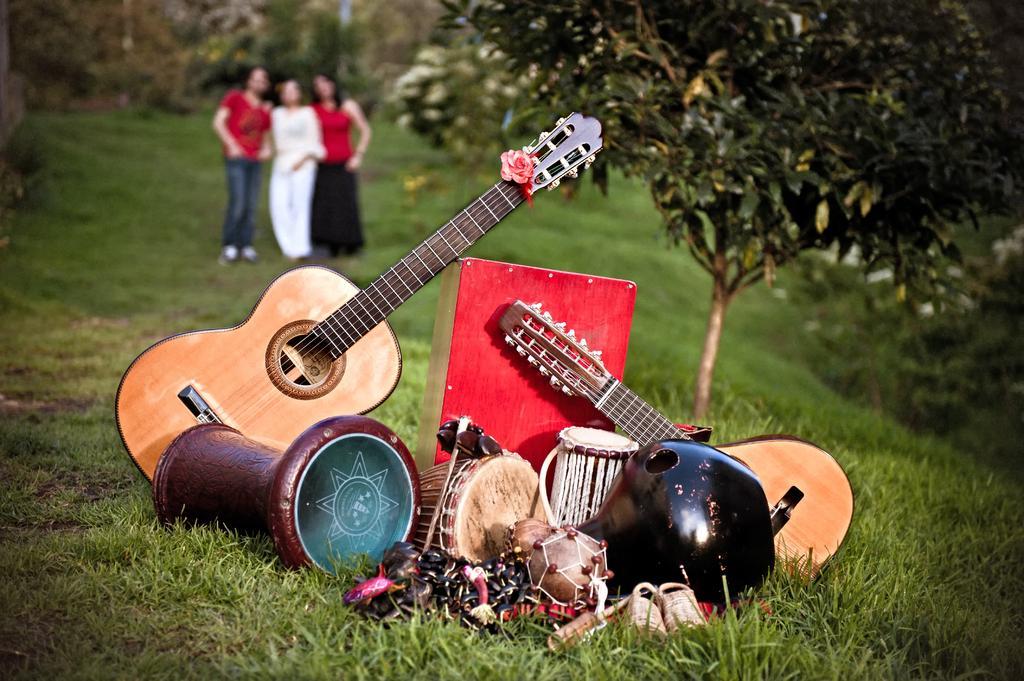Describe this image in one or two sentences. In this picture we can see some musical instruments. Here we can see three persons are standing on the grass. And these are the trees. 